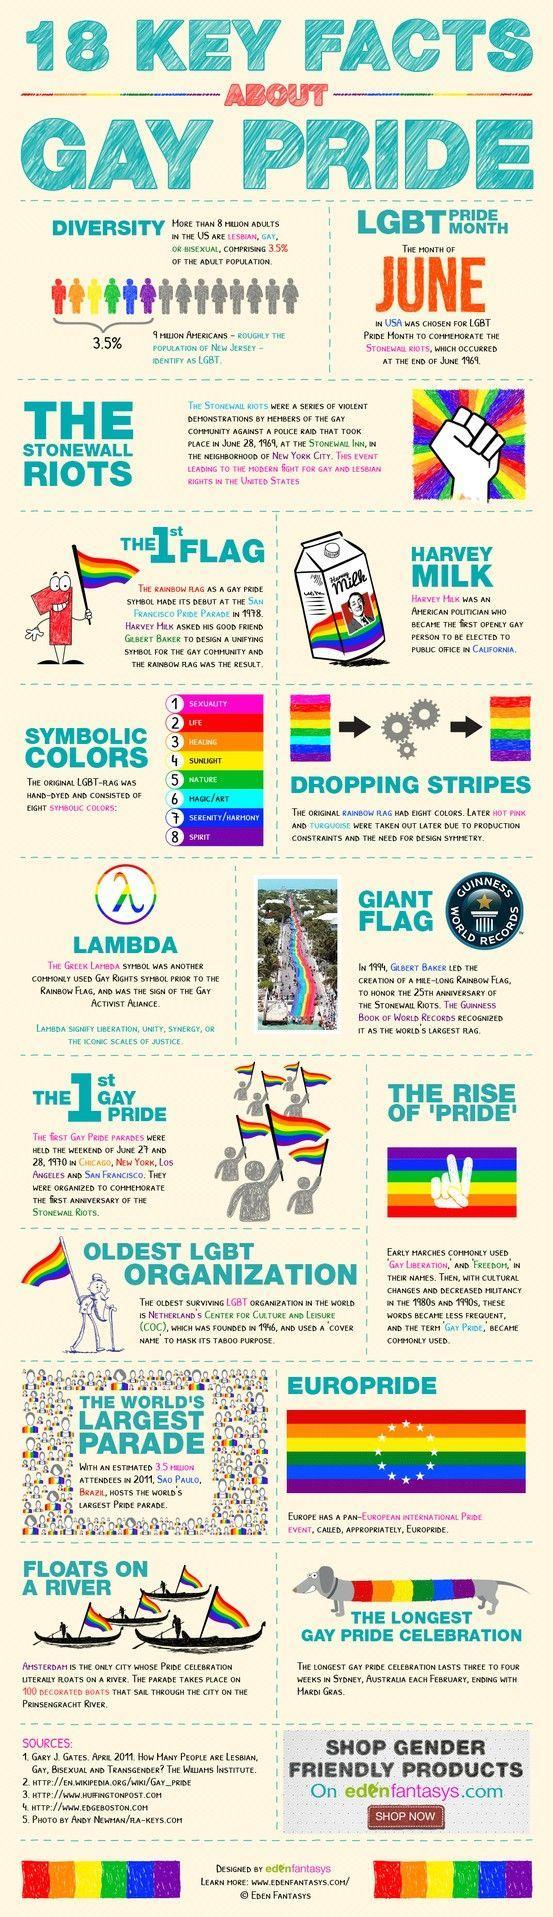What does colour red in the LBT flag signify?
Answer the question with a short phrase. LIFE 